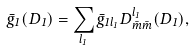<formula> <loc_0><loc_0><loc_500><loc_500>\bar { g } _ { 1 } ( D _ { 1 } ) = \sum _ { l _ { 1 } } \bar { g } _ { 1 l _ { 1 } } D _ { \bar { m } \bar { m } } ^ { l _ { 1 } } ( D _ { 1 } ) ,</formula> 